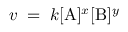<formula> <loc_0><loc_0><loc_500><loc_500>v \, = \, k [ A ] ^ { x } [ B ] ^ { y }</formula> 